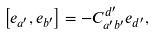Convert formula to latex. <formula><loc_0><loc_0><loc_500><loc_500>\left [ e _ { a ^ { \prime } } , e _ { b ^ { \prime } } \right ] = - C _ { a ^ { \prime } b ^ { \prime } } ^ { d ^ { \prime } } e _ { d ^ { \prime } } ,</formula> 